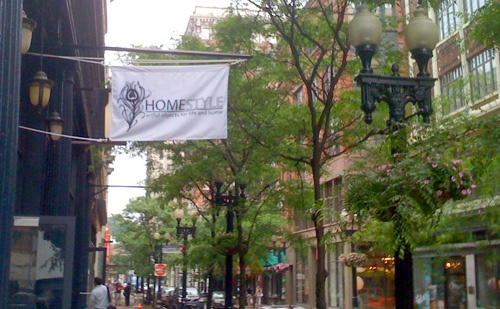Describe the objects in this image and their specific colors. I can see people in purple, gray, darkgray, and black tones, car in purple, gray, black, darkgray, and lightgray tones, car in purple, gray, black, and darkgray tones, car in purple, gray, darkgray, black, and lightgray tones, and car in purple, gray, darkgray, lightgray, and black tones in this image. 